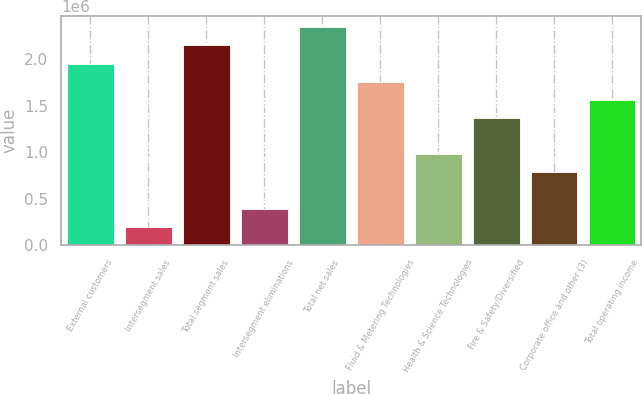Convert chart to OTSL. <chart><loc_0><loc_0><loc_500><loc_500><bar_chart><fcel>External customers<fcel>Intersegment sales<fcel>Total segment sales<fcel>Intersegment eliminations<fcel>Total net sales<fcel>Fluid & Metering Technologies<fcel>Health & Science Technologies<fcel>Fire & Safety/Diversified<fcel>Corporate office and other (3)<fcel>Total operating income<nl><fcel>1.95426e+06<fcel>195638<fcel>2.14966e+06<fcel>391040<fcel>2.34506e+06<fcel>1.75886e+06<fcel>977247<fcel>1.36805e+06<fcel>781845<fcel>1.56345e+06<nl></chart> 